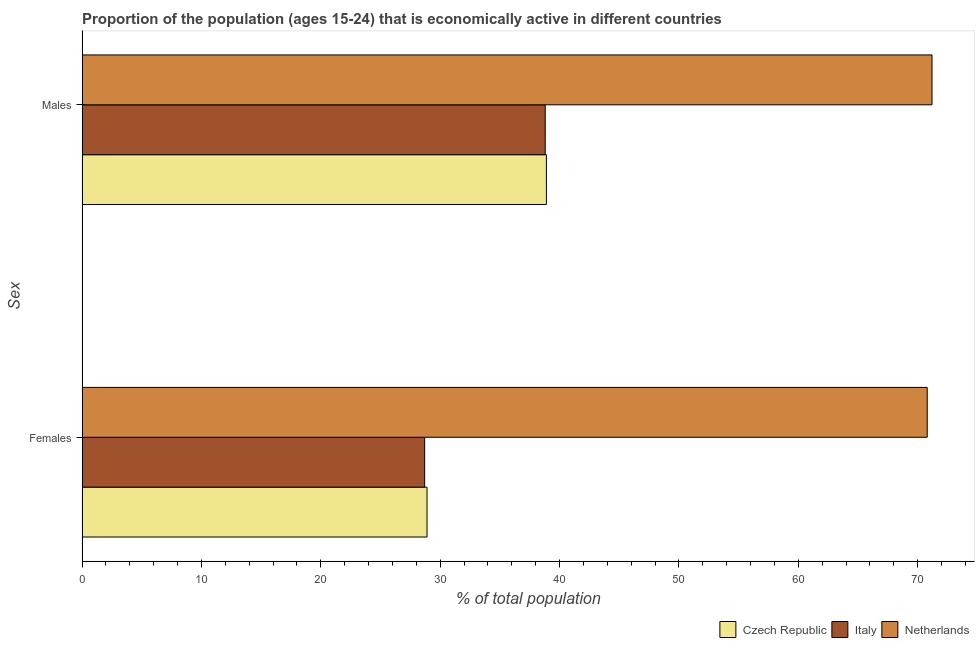How many different coloured bars are there?
Your answer should be compact. 3. How many groups of bars are there?
Provide a short and direct response. 2. Are the number of bars per tick equal to the number of legend labels?
Offer a terse response. Yes. How many bars are there on the 2nd tick from the top?
Your answer should be compact. 3. What is the label of the 1st group of bars from the top?
Your answer should be very brief. Males. What is the percentage of economically active female population in Czech Republic?
Your response must be concise. 28.9. Across all countries, what is the maximum percentage of economically active female population?
Make the answer very short. 70.8. Across all countries, what is the minimum percentage of economically active male population?
Your answer should be very brief. 38.8. What is the total percentage of economically active female population in the graph?
Offer a very short reply. 128.4. What is the difference between the percentage of economically active female population in Italy and that in Czech Republic?
Ensure brevity in your answer.  -0.2. What is the difference between the percentage of economically active female population in Czech Republic and the percentage of economically active male population in Italy?
Ensure brevity in your answer.  -9.9. What is the average percentage of economically active female population per country?
Provide a succinct answer. 42.8. What is the difference between the percentage of economically active male population and percentage of economically active female population in Italy?
Keep it short and to the point. 10.1. In how many countries, is the percentage of economically active male population greater than 62 %?
Give a very brief answer. 1. What is the ratio of the percentage of economically active male population in Czech Republic to that in Netherlands?
Your answer should be very brief. 0.55. Is the percentage of economically active male population in Czech Republic less than that in Netherlands?
Give a very brief answer. Yes. What does the 1st bar from the bottom in Males represents?
Your answer should be compact. Czech Republic. How many bars are there?
Your answer should be compact. 6. Are the values on the major ticks of X-axis written in scientific E-notation?
Your answer should be compact. No. Does the graph contain any zero values?
Ensure brevity in your answer.  No. Does the graph contain grids?
Make the answer very short. No. Where does the legend appear in the graph?
Offer a terse response. Bottom right. How many legend labels are there?
Provide a short and direct response. 3. What is the title of the graph?
Give a very brief answer. Proportion of the population (ages 15-24) that is economically active in different countries. What is the label or title of the X-axis?
Keep it short and to the point. % of total population. What is the label or title of the Y-axis?
Keep it short and to the point. Sex. What is the % of total population of Czech Republic in Females?
Offer a terse response. 28.9. What is the % of total population of Italy in Females?
Provide a short and direct response. 28.7. What is the % of total population in Netherlands in Females?
Your response must be concise. 70.8. What is the % of total population in Czech Republic in Males?
Your answer should be compact. 38.9. What is the % of total population in Italy in Males?
Your answer should be compact. 38.8. What is the % of total population of Netherlands in Males?
Make the answer very short. 71.2. Across all Sex, what is the maximum % of total population of Czech Republic?
Offer a very short reply. 38.9. Across all Sex, what is the maximum % of total population of Italy?
Make the answer very short. 38.8. Across all Sex, what is the maximum % of total population of Netherlands?
Your answer should be very brief. 71.2. Across all Sex, what is the minimum % of total population in Czech Republic?
Keep it short and to the point. 28.9. Across all Sex, what is the minimum % of total population of Italy?
Ensure brevity in your answer.  28.7. Across all Sex, what is the minimum % of total population in Netherlands?
Offer a very short reply. 70.8. What is the total % of total population in Czech Republic in the graph?
Offer a very short reply. 67.8. What is the total % of total population of Italy in the graph?
Provide a succinct answer. 67.5. What is the total % of total population of Netherlands in the graph?
Provide a short and direct response. 142. What is the difference between the % of total population in Czech Republic in Females and that in Males?
Ensure brevity in your answer.  -10. What is the difference between the % of total population in Italy in Females and that in Males?
Your answer should be compact. -10.1. What is the difference between the % of total population of Czech Republic in Females and the % of total population of Netherlands in Males?
Make the answer very short. -42.3. What is the difference between the % of total population in Italy in Females and the % of total population in Netherlands in Males?
Provide a short and direct response. -42.5. What is the average % of total population of Czech Republic per Sex?
Provide a short and direct response. 33.9. What is the average % of total population in Italy per Sex?
Provide a short and direct response. 33.75. What is the difference between the % of total population of Czech Republic and % of total population of Italy in Females?
Keep it short and to the point. 0.2. What is the difference between the % of total population of Czech Republic and % of total population of Netherlands in Females?
Keep it short and to the point. -41.9. What is the difference between the % of total population of Italy and % of total population of Netherlands in Females?
Provide a succinct answer. -42.1. What is the difference between the % of total population in Czech Republic and % of total population in Netherlands in Males?
Your answer should be very brief. -32.3. What is the difference between the % of total population of Italy and % of total population of Netherlands in Males?
Your answer should be compact. -32.4. What is the ratio of the % of total population of Czech Republic in Females to that in Males?
Your answer should be very brief. 0.74. What is the ratio of the % of total population of Italy in Females to that in Males?
Ensure brevity in your answer.  0.74. What is the ratio of the % of total population in Netherlands in Females to that in Males?
Keep it short and to the point. 0.99. What is the difference between the highest and the second highest % of total population of Czech Republic?
Provide a short and direct response. 10. What is the difference between the highest and the lowest % of total population in Italy?
Keep it short and to the point. 10.1. What is the difference between the highest and the lowest % of total population in Netherlands?
Offer a very short reply. 0.4. 